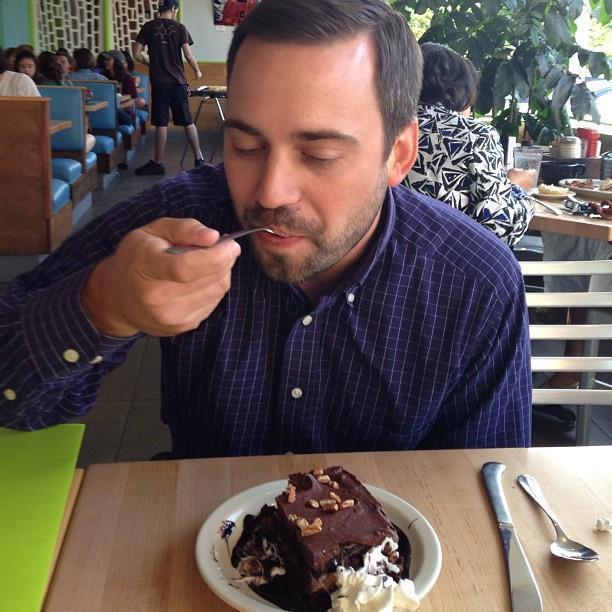What type of restaurant is this?
Answer the question by selecting the correct answer among the 4 following choices.
Options: Chinese, diner, moroccan, tavern. Diner. 